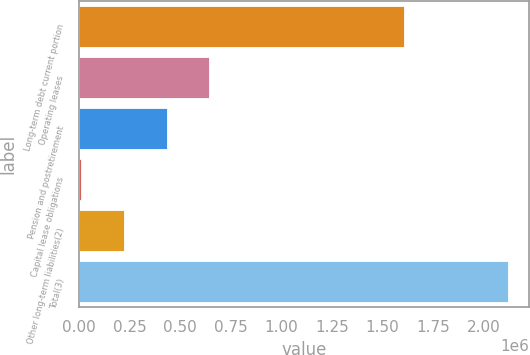<chart> <loc_0><loc_0><loc_500><loc_500><bar_chart><fcel>Long-term debt current portion<fcel>Operating leases<fcel>Pension and postretirement<fcel>Capital lease obligations<fcel>Other long-term liabilities(2)<fcel>Total(3)<nl><fcel>1.60526e+06<fcel>643433<fcel>432784<fcel>11487<fcel>222136<fcel>2.11797e+06<nl></chart> 